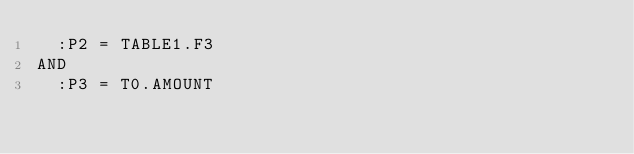Convert code to text. <code><loc_0><loc_0><loc_500><loc_500><_SQL_>  :P2 = TABLE1.F3
AND
  :P3 = T0.AMOUNT
</code> 